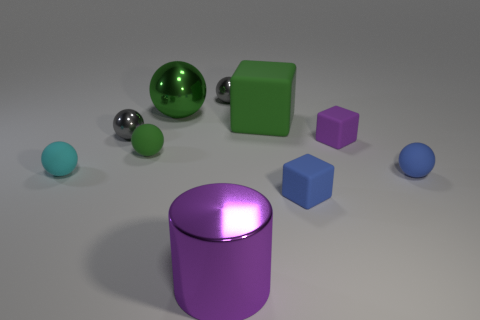Is there anything else that is the same shape as the large purple metallic object?
Your answer should be compact. No. The thing that is both to the left of the large green matte object and in front of the cyan ball has what shape?
Your answer should be compact. Cylinder. What is the color of the rubber sphere right of the small rubber block that is in front of the rubber sphere that is on the right side of the tiny blue matte block?
Your answer should be compact. Blue. There is a cylinder; does it have the same size as the green thing in front of the purple matte block?
Your answer should be compact. No. What number of things are gray metal objects that are to the right of the purple shiny cylinder or spheres that are on the left side of the tiny purple object?
Provide a succinct answer. 5. What is the shape of the matte thing that is the same size as the purple metallic thing?
Offer a terse response. Cube. What shape is the large thing in front of the small blue object in front of the ball that is to the right of the purple matte block?
Give a very brief answer. Cylinder. Is the number of blue balls behind the tiny green sphere the same as the number of blue objects?
Make the answer very short. No. Is the green metal sphere the same size as the green cube?
Give a very brief answer. Yes. How many shiny objects are either big cyan blocks or tiny green balls?
Your response must be concise. 0. 